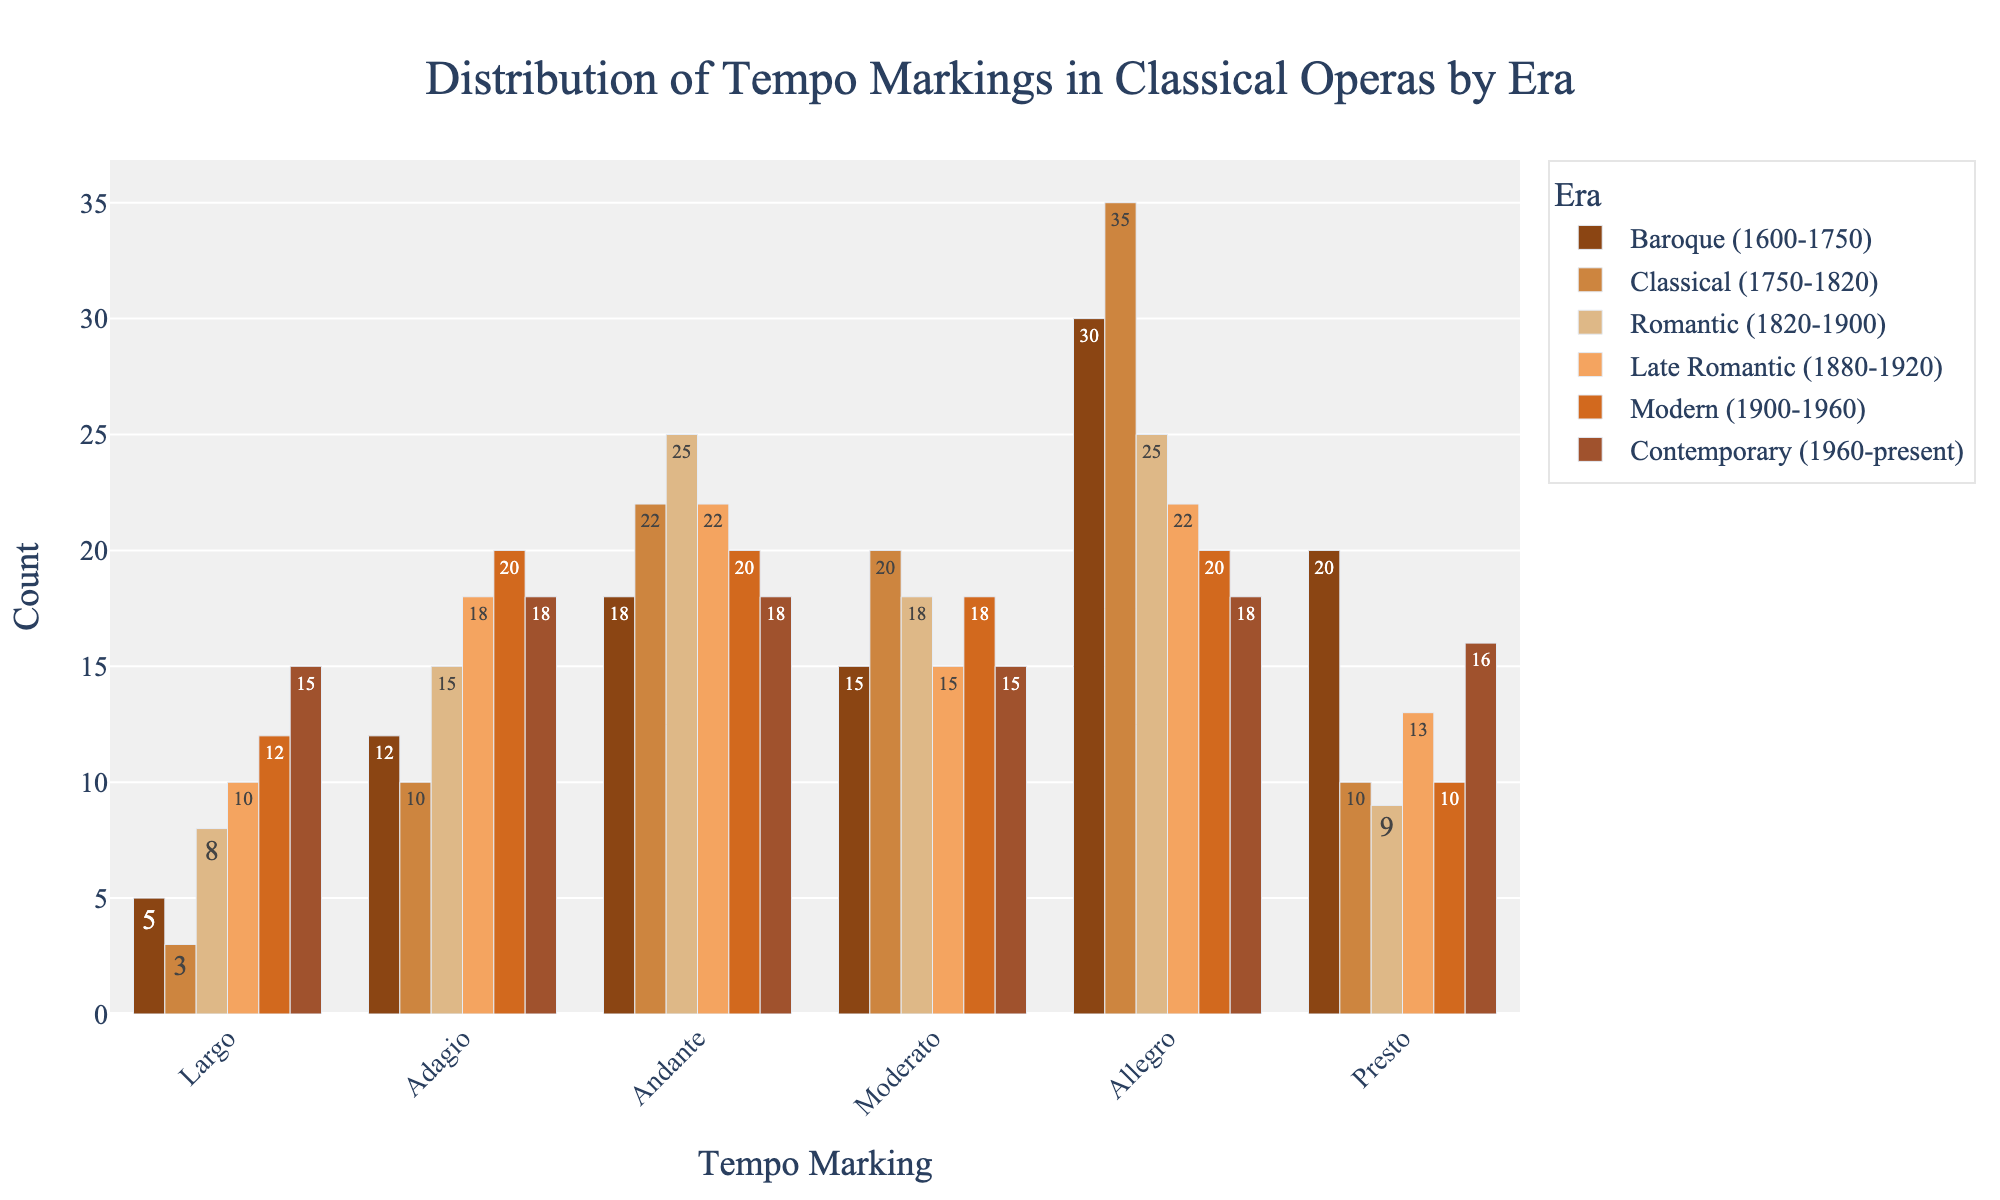What's the era with the highest number of Andante tempo markings? Look at the Andante column and compare the heights of bars across different eras to identify the highest one. The Romantic era has the highest bar in the Andante tempo marking.
Answer: Romantic (1820-1900) Which tempo marking has a consistent number of occurrences across all eras? Check if any column (tempo marking) has bars of roughly the same height across all the eras. Adagio tempo marking has consistent numbers across different eras.
Answer: Adagio How many Largo markings are there in total across all eras? Sum the heights of all bars in the Largo column. 5 + 3 + 8 + 10 + 12 + 15 = 53.
Answer: 53 Which tempo marking decreases in number from the Baroque to Classical eras and then increases in the Romantic era? Follow the bars by tempo marking from Baroque to Classical to Romantic. Presto shows a decrease from Baroque (20) to Classical (10), then an increase in Romantic (9).
Answer: Presto Which era has the most varied distribution of tempo markings? Identify the era with the most uneven heights of bars across different tempo markings. Modern (1900-1960) era has a noticeably varied distribution with counts ranging from 10 to 20.
Answer: Modern (1900-1960) How many more Adagio markings are there in the Modern era compared to the Classical era? Subtract the number of Adagio markings in the Classical era from that in the Modern era. 20 - 10 = 10.
Answer: 10 In which era do Andante and Moderato markings have the same count? Look for an era where the heights of the Andante and Moderato bars are equal. In Contemporary (1960-present) era, Andante and Moderato are both 18.
Answer: Contemporary (1960-present) Which era has the least number of fast tempo markings (Allegro and Presto combined)? Sum the counts of Allegro and Presto for each era, and identify the smallest sum. Classical (1750-1820) has Allegro (35) + Presto (10) = 45, which is the smallest.
Answer: Classical (1750-1820) Is the number of Allegro markings greater in the Classical era or the Romantic era? Compare the heights of Allegro bars in the Classical and Romantic eras. The Classical era has 35 Allegro markings, and the Romantic era has 25.
Answer: Classical (1750-1820) Which tempo markings peak in the Baroque era? Identify the tempo markings with the highest bar for the Baroque era compared to other eras. Largo (5) and Moderato (15) are at their peak in the Baroque era.
Answer: Largo, Moderato 